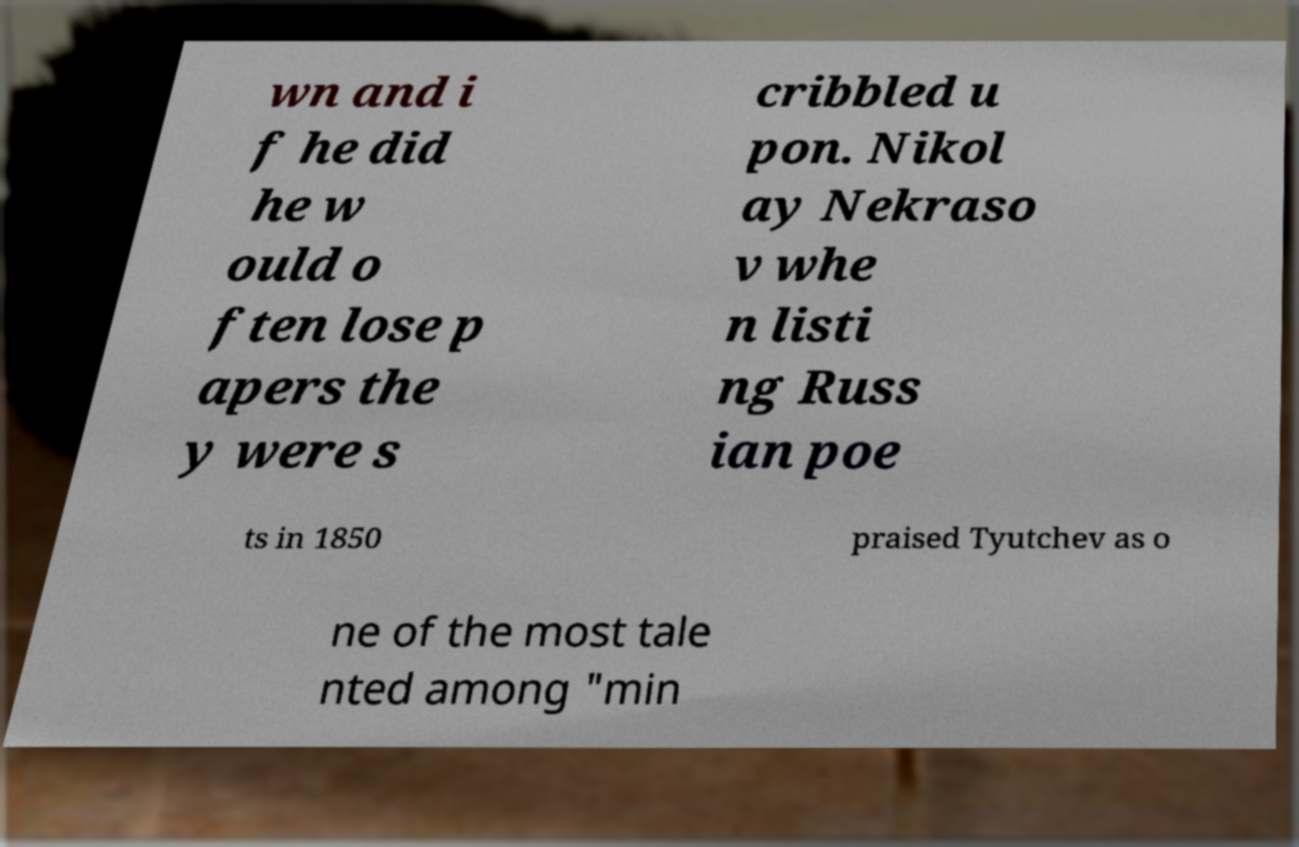Can you accurately transcribe the text from the provided image for me? wn and i f he did he w ould o ften lose p apers the y were s cribbled u pon. Nikol ay Nekraso v whe n listi ng Russ ian poe ts in 1850 praised Tyutchev as o ne of the most tale nted among "min 